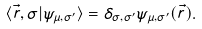<formula> <loc_0><loc_0><loc_500><loc_500>\langle \vec { r } , \sigma | \psi _ { \mu , \sigma ^ { \prime } } \rangle = \delta _ { \sigma , \sigma ^ { \prime } } \psi _ { \mu , \sigma ^ { \prime } } ( \vec { r } ) .</formula> 